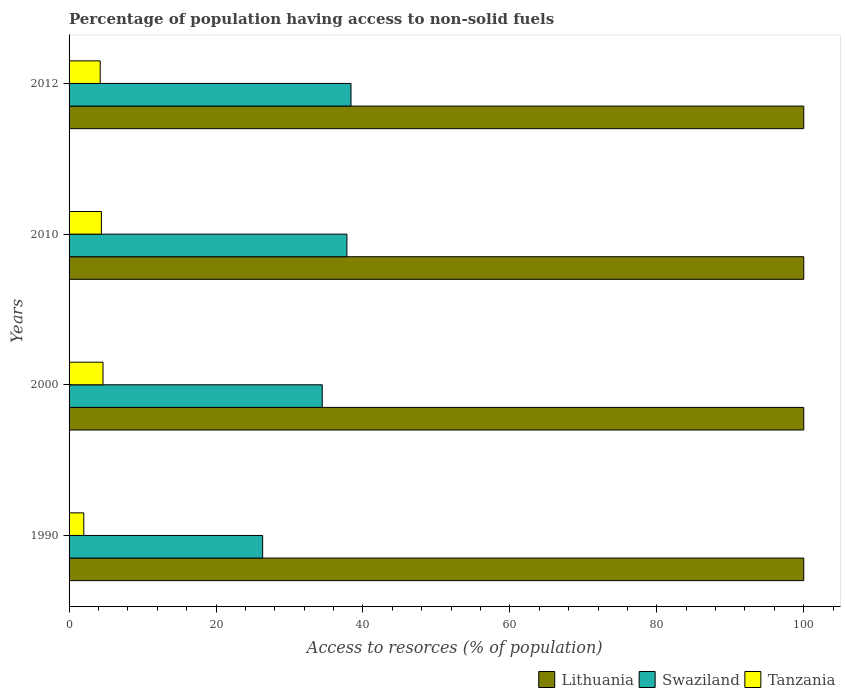Are the number of bars per tick equal to the number of legend labels?
Your answer should be very brief. Yes. What is the label of the 1st group of bars from the top?
Provide a succinct answer. 2012. In how many cases, is the number of bars for a given year not equal to the number of legend labels?
Your answer should be compact. 0. What is the percentage of population having access to non-solid fuels in Tanzania in 2000?
Keep it short and to the point. 4.62. Across all years, what is the maximum percentage of population having access to non-solid fuels in Swaziland?
Offer a very short reply. 38.37. Across all years, what is the minimum percentage of population having access to non-solid fuels in Swaziland?
Make the answer very short. 26.35. What is the total percentage of population having access to non-solid fuels in Tanzania in the graph?
Make the answer very short. 15.26. What is the difference between the percentage of population having access to non-solid fuels in Swaziland in 2000 and that in 2010?
Make the answer very short. -3.36. What is the difference between the percentage of population having access to non-solid fuels in Swaziland in 2000 and the percentage of population having access to non-solid fuels in Tanzania in 2012?
Offer a terse response. 30.22. What is the average percentage of population having access to non-solid fuels in Swaziland per year?
Your answer should be compact. 34.25. In the year 1990, what is the difference between the percentage of population having access to non-solid fuels in Lithuania and percentage of population having access to non-solid fuels in Tanzania?
Keep it short and to the point. 97.99. In how many years, is the percentage of population having access to non-solid fuels in Lithuania greater than 28 %?
Provide a succinct answer. 4. What is the ratio of the percentage of population having access to non-solid fuels in Tanzania in 1990 to that in 2012?
Your answer should be compact. 0.47. Is the difference between the percentage of population having access to non-solid fuels in Lithuania in 2010 and 2012 greater than the difference between the percentage of population having access to non-solid fuels in Tanzania in 2010 and 2012?
Your response must be concise. No. What is the difference between the highest and the lowest percentage of population having access to non-solid fuels in Tanzania?
Make the answer very short. 2.62. In how many years, is the percentage of population having access to non-solid fuels in Tanzania greater than the average percentage of population having access to non-solid fuels in Tanzania taken over all years?
Provide a short and direct response. 3. What does the 1st bar from the top in 1990 represents?
Give a very brief answer. Tanzania. What does the 1st bar from the bottom in 2010 represents?
Offer a terse response. Lithuania. How many bars are there?
Ensure brevity in your answer.  12. Are all the bars in the graph horizontal?
Provide a succinct answer. Yes. What is the difference between two consecutive major ticks on the X-axis?
Make the answer very short. 20. Does the graph contain any zero values?
Ensure brevity in your answer.  No. Does the graph contain grids?
Offer a terse response. No. Where does the legend appear in the graph?
Your answer should be very brief. Bottom right. What is the title of the graph?
Provide a succinct answer. Percentage of population having access to non-solid fuels. What is the label or title of the X-axis?
Your answer should be compact. Access to resorces (% of population). What is the Access to resorces (% of population) of Lithuania in 1990?
Your response must be concise. 100. What is the Access to resorces (% of population) in Swaziland in 1990?
Ensure brevity in your answer.  26.35. What is the Access to resorces (% of population) of Tanzania in 1990?
Give a very brief answer. 2.01. What is the Access to resorces (% of population) in Swaziland in 2000?
Make the answer very short. 34.46. What is the Access to resorces (% of population) of Tanzania in 2000?
Provide a succinct answer. 4.62. What is the Access to resorces (% of population) in Lithuania in 2010?
Offer a very short reply. 100. What is the Access to resorces (% of population) in Swaziland in 2010?
Offer a terse response. 37.82. What is the Access to resorces (% of population) of Tanzania in 2010?
Provide a short and direct response. 4.4. What is the Access to resorces (% of population) in Swaziland in 2012?
Offer a very short reply. 38.37. What is the Access to resorces (% of population) in Tanzania in 2012?
Your answer should be compact. 4.24. Across all years, what is the maximum Access to resorces (% of population) of Swaziland?
Make the answer very short. 38.37. Across all years, what is the maximum Access to resorces (% of population) of Tanzania?
Make the answer very short. 4.62. Across all years, what is the minimum Access to resorces (% of population) in Swaziland?
Your answer should be compact. 26.35. Across all years, what is the minimum Access to resorces (% of population) in Tanzania?
Provide a succinct answer. 2.01. What is the total Access to resorces (% of population) in Lithuania in the graph?
Your answer should be compact. 400. What is the total Access to resorces (% of population) of Swaziland in the graph?
Provide a succinct answer. 137. What is the total Access to resorces (% of population) of Tanzania in the graph?
Your answer should be very brief. 15.26. What is the difference between the Access to resorces (% of population) of Swaziland in 1990 and that in 2000?
Your response must be concise. -8.11. What is the difference between the Access to resorces (% of population) in Tanzania in 1990 and that in 2000?
Your answer should be compact. -2.62. What is the difference between the Access to resorces (% of population) in Lithuania in 1990 and that in 2010?
Your response must be concise. 0. What is the difference between the Access to resorces (% of population) in Swaziland in 1990 and that in 2010?
Provide a short and direct response. -11.47. What is the difference between the Access to resorces (% of population) in Tanzania in 1990 and that in 2010?
Make the answer very short. -2.39. What is the difference between the Access to resorces (% of population) of Lithuania in 1990 and that in 2012?
Offer a terse response. 0. What is the difference between the Access to resorces (% of population) in Swaziland in 1990 and that in 2012?
Keep it short and to the point. -12.02. What is the difference between the Access to resorces (% of population) in Tanzania in 1990 and that in 2012?
Your answer should be compact. -2.23. What is the difference between the Access to resorces (% of population) of Lithuania in 2000 and that in 2010?
Give a very brief answer. 0. What is the difference between the Access to resorces (% of population) of Swaziland in 2000 and that in 2010?
Your answer should be compact. -3.36. What is the difference between the Access to resorces (% of population) in Tanzania in 2000 and that in 2010?
Offer a terse response. 0.22. What is the difference between the Access to resorces (% of population) in Swaziland in 2000 and that in 2012?
Your answer should be very brief. -3.91. What is the difference between the Access to resorces (% of population) in Tanzania in 2000 and that in 2012?
Your answer should be compact. 0.38. What is the difference between the Access to resorces (% of population) of Swaziland in 2010 and that in 2012?
Ensure brevity in your answer.  -0.56. What is the difference between the Access to resorces (% of population) of Tanzania in 2010 and that in 2012?
Offer a terse response. 0.16. What is the difference between the Access to resorces (% of population) in Lithuania in 1990 and the Access to resorces (% of population) in Swaziland in 2000?
Make the answer very short. 65.54. What is the difference between the Access to resorces (% of population) of Lithuania in 1990 and the Access to resorces (% of population) of Tanzania in 2000?
Ensure brevity in your answer.  95.38. What is the difference between the Access to resorces (% of population) of Swaziland in 1990 and the Access to resorces (% of population) of Tanzania in 2000?
Your response must be concise. 21.73. What is the difference between the Access to resorces (% of population) in Lithuania in 1990 and the Access to resorces (% of population) in Swaziland in 2010?
Provide a succinct answer. 62.18. What is the difference between the Access to resorces (% of population) in Lithuania in 1990 and the Access to resorces (% of population) in Tanzania in 2010?
Ensure brevity in your answer.  95.6. What is the difference between the Access to resorces (% of population) of Swaziland in 1990 and the Access to resorces (% of population) of Tanzania in 2010?
Offer a terse response. 21.95. What is the difference between the Access to resorces (% of population) of Lithuania in 1990 and the Access to resorces (% of population) of Swaziland in 2012?
Make the answer very short. 61.63. What is the difference between the Access to resorces (% of population) of Lithuania in 1990 and the Access to resorces (% of population) of Tanzania in 2012?
Offer a terse response. 95.76. What is the difference between the Access to resorces (% of population) of Swaziland in 1990 and the Access to resorces (% of population) of Tanzania in 2012?
Give a very brief answer. 22.11. What is the difference between the Access to resorces (% of population) in Lithuania in 2000 and the Access to resorces (% of population) in Swaziland in 2010?
Provide a succinct answer. 62.18. What is the difference between the Access to resorces (% of population) in Lithuania in 2000 and the Access to resorces (% of population) in Tanzania in 2010?
Provide a succinct answer. 95.6. What is the difference between the Access to resorces (% of population) of Swaziland in 2000 and the Access to resorces (% of population) of Tanzania in 2010?
Your answer should be compact. 30.06. What is the difference between the Access to resorces (% of population) in Lithuania in 2000 and the Access to resorces (% of population) in Swaziland in 2012?
Keep it short and to the point. 61.63. What is the difference between the Access to resorces (% of population) of Lithuania in 2000 and the Access to resorces (% of population) of Tanzania in 2012?
Ensure brevity in your answer.  95.76. What is the difference between the Access to resorces (% of population) of Swaziland in 2000 and the Access to resorces (% of population) of Tanzania in 2012?
Keep it short and to the point. 30.22. What is the difference between the Access to resorces (% of population) of Lithuania in 2010 and the Access to resorces (% of population) of Swaziland in 2012?
Your answer should be very brief. 61.63. What is the difference between the Access to resorces (% of population) of Lithuania in 2010 and the Access to resorces (% of population) of Tanzania in 2012?
Offer a terse response. 95.76. What is the difference between the Access to resorces (% of population) in Swaziland in 2010 and the Access to resorces (% of population) in Tanzania in 2012?
Give a very brief answer. 33.58. What is the average Access to resorces (% of population) of Swaziland per year?
Provide a succinct answer. 34.25. What is the average Access to resorces (% of population) in Tanzania per year?
Make the answer very short. 3.81. In the year 1990, what is the difference between the Access to resorces (% of population) of Lithuania and Access to resorces (% of population) of Swaziland?
Provide a succinct answer. 73.65. In the year 1990, what is the difference between the Access to resorces (% of population) in Lithuania and Access to resorces (% of population) in Tanzania?
Make the answer very short. 97.99. In the year 1990, what is the difference between the Access to resorces (% of population) in Swaziland and Access to resorces (% of population) in Tanzania?
Offer a very short reply. 24.35. In the year 2000, what is the difference between the Access to resorces (% of population) of Lithuania and Access to resorces (% of population) of Swaziland?
Your answer should be compact. 65.54. In the year 2000, what is the difference between the Access to resorces (% of population) in Lithuania and Access to resorces (% of population) in Tanzania?
Ensure brevity in your answer.  95.38. In the year 2000, what is the difference between the Access to resorces (% of population) in Swaziland and Access to resorces (% of population) in Tanzania?
Provide a short and direct response. 29.84. In the year 2010, what is the difference between the Access to resorces (% of population) in Lithuania and Access to resorces (% of population) in Swaziland?
Keep it short and to the point. 62.18. In the year 2010, what is the difference between the Access to resorces (% of population) of Lithuania and Access to resorces (% of population) of Tanzania?
Make the answer very short. 95.6. In the year 2010, what is the difference between the Access to resorces (% of population) in Swaziland and Access to resorces (% of population) in Tanzania?
Ensure brevity in your answer.  33.42. In the year 2012, what is the difference between the Access to resorces (% of population) in Lithuania and Access to resorces (% of population) in Swaziland?
Your answer should be compact. 61.63. In the year 2012, what is the difference between the Access to resorces (% of population) in Lithuania and Access to resorces (% of population) in Tanzania?
Your answer should be very brief. 95.76. In the year 2012, what is the difference between the Access to resorces (% of population) of Swaziland and Access to resorces (% of population) of Tanzania?
Provide a short and direct response. 34.14. What is the ratio of the Access to resorces (% of population) of Lithuania in 1990 to that in 2000?
Provide a short and direct response. 1. What is the ratio of the Access to resorces (% of population) of Swaziland in 1990 to that in 2000?
Ensure brevity in your answer.  0.76. What is the ratio of the Access to resorces (% of population) of Tanzania in 1990 to that in 2000?
Keep it short and to the point. 0.43. What is the ratio of the Access to resorces (% of population) of Swaziland in 1990 to that in 2010?
Your answer should be compact. 0.7. What is the ratio of the Access to resorces (% of population) in Tanzania in 1990 to that in 2010?
Offer a terse response. 0.46. What is the ratio of the Access to resorces (% of population) in Swaziland in 1990 to that in 2012?
Keep it short and to the point. 0.69. What is the ratio of the Access to resorces (% of population) in Tanzania in 1990 to that in 2012?
Provide a succinct answer. 0.47. What is the ratio of the Access to resorces (% of population) of Swaziland in 2000 to that in 2010?
Offer a terse response. 0.91. What is the ratio of the Access to resorces (% of population) in Tanzania in 2000 to that in 2010?
Your answer should be compact. 1.05. What is the ratio of the Access to resorces (% of population) in Swaziland in 2000 to that in 2012?
Offer a very short reply. 0.9. What is the ratio of the Access to resorces (% of population) in Tanzania in 2000 to that in 2012?
Offer a terse response. 1.09. What is the ratio of the Access to resorces (% of population) of Swaziland in 2010 to that in 2012?
Give a very brief answer. 0.99. What is the ratio of the Access to resorces (% of population) of Tanzania in 2010 to that in 2012?
Your answer should be compact. 1.04. What is the difference between the highest and the second highest Access to resorces (% of population) of Lithuania?
Provide a short and direct response. 0. What is the difference between the highest and the second highest Access to resorces (% of population) in Swaziland?
Your response must be concise. 0.56. What is the difference between the highest and the second highest Access to resorces (% of population) of Tanzania?
Offer a terse response. 0.22. What is the difference between the highest and the lowest Access to resorces (% of population) of Lithuania?
Keep it short and to the point. 0. What is the difference between the highest and the lowest Access to resorces (% of population) of Swaziland?
Provide a succinct answer. 12.02. What is the difference between the highest and the lowest Access to resorces (% of population) of Tanzania?
Your answer should be compact. 2.62. 